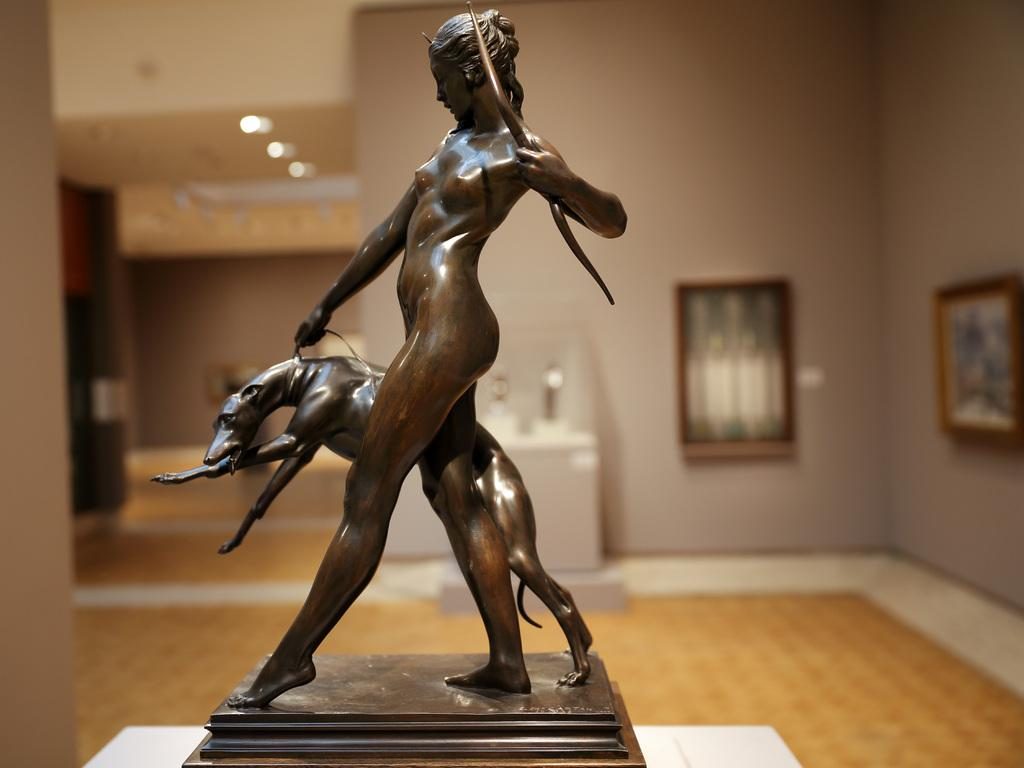What is the main subject of the image? There is a sculpture with a stand in the image. What is the color of the surface the sculpture is placed on? The sculpture is on a white surface. Can you describe the background of the image? The background of the image has a blurred view, and there is a wall with photo frames in it. What parts of the room can be seen in the image? The floor, ceiling, and lights are visible in the image. What else can be seen in the image besides the sculpture? There are some objects in the image. What type of fish can be seen swimming in the image? There are no fish present in the image; it features a sculpture on a white surface with a blurred background. What is the sculpture writing on the white surface? The sculpture is not writing anything in the image; it is a stationary object. 